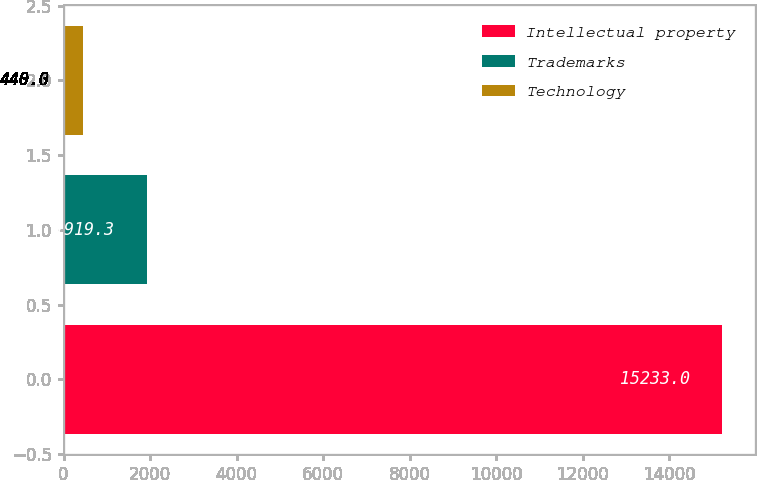<chart> <loc_0><loc_0><loc_500><loc_500><bar_chart><fcel>Intellectual property<fcel>Trademarks<fcel>Technology<nl><fcel>15233<fcel>1919.3<fcel>440<nl></chart> 